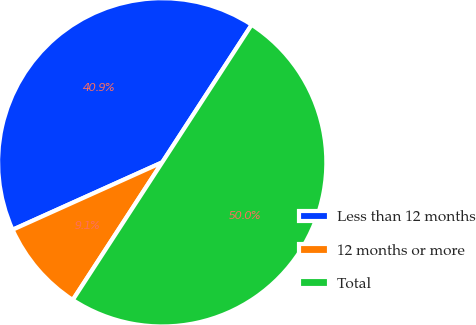<chart> <loc_0><loc_0><loc_500><loc_500><pie_chart><fcel>Less than 12 months<fcel>12 months or more<fcel>Total<nl><fcel>40.91%<fcel>9.09%<fcel>50.0%<nl></chart> 